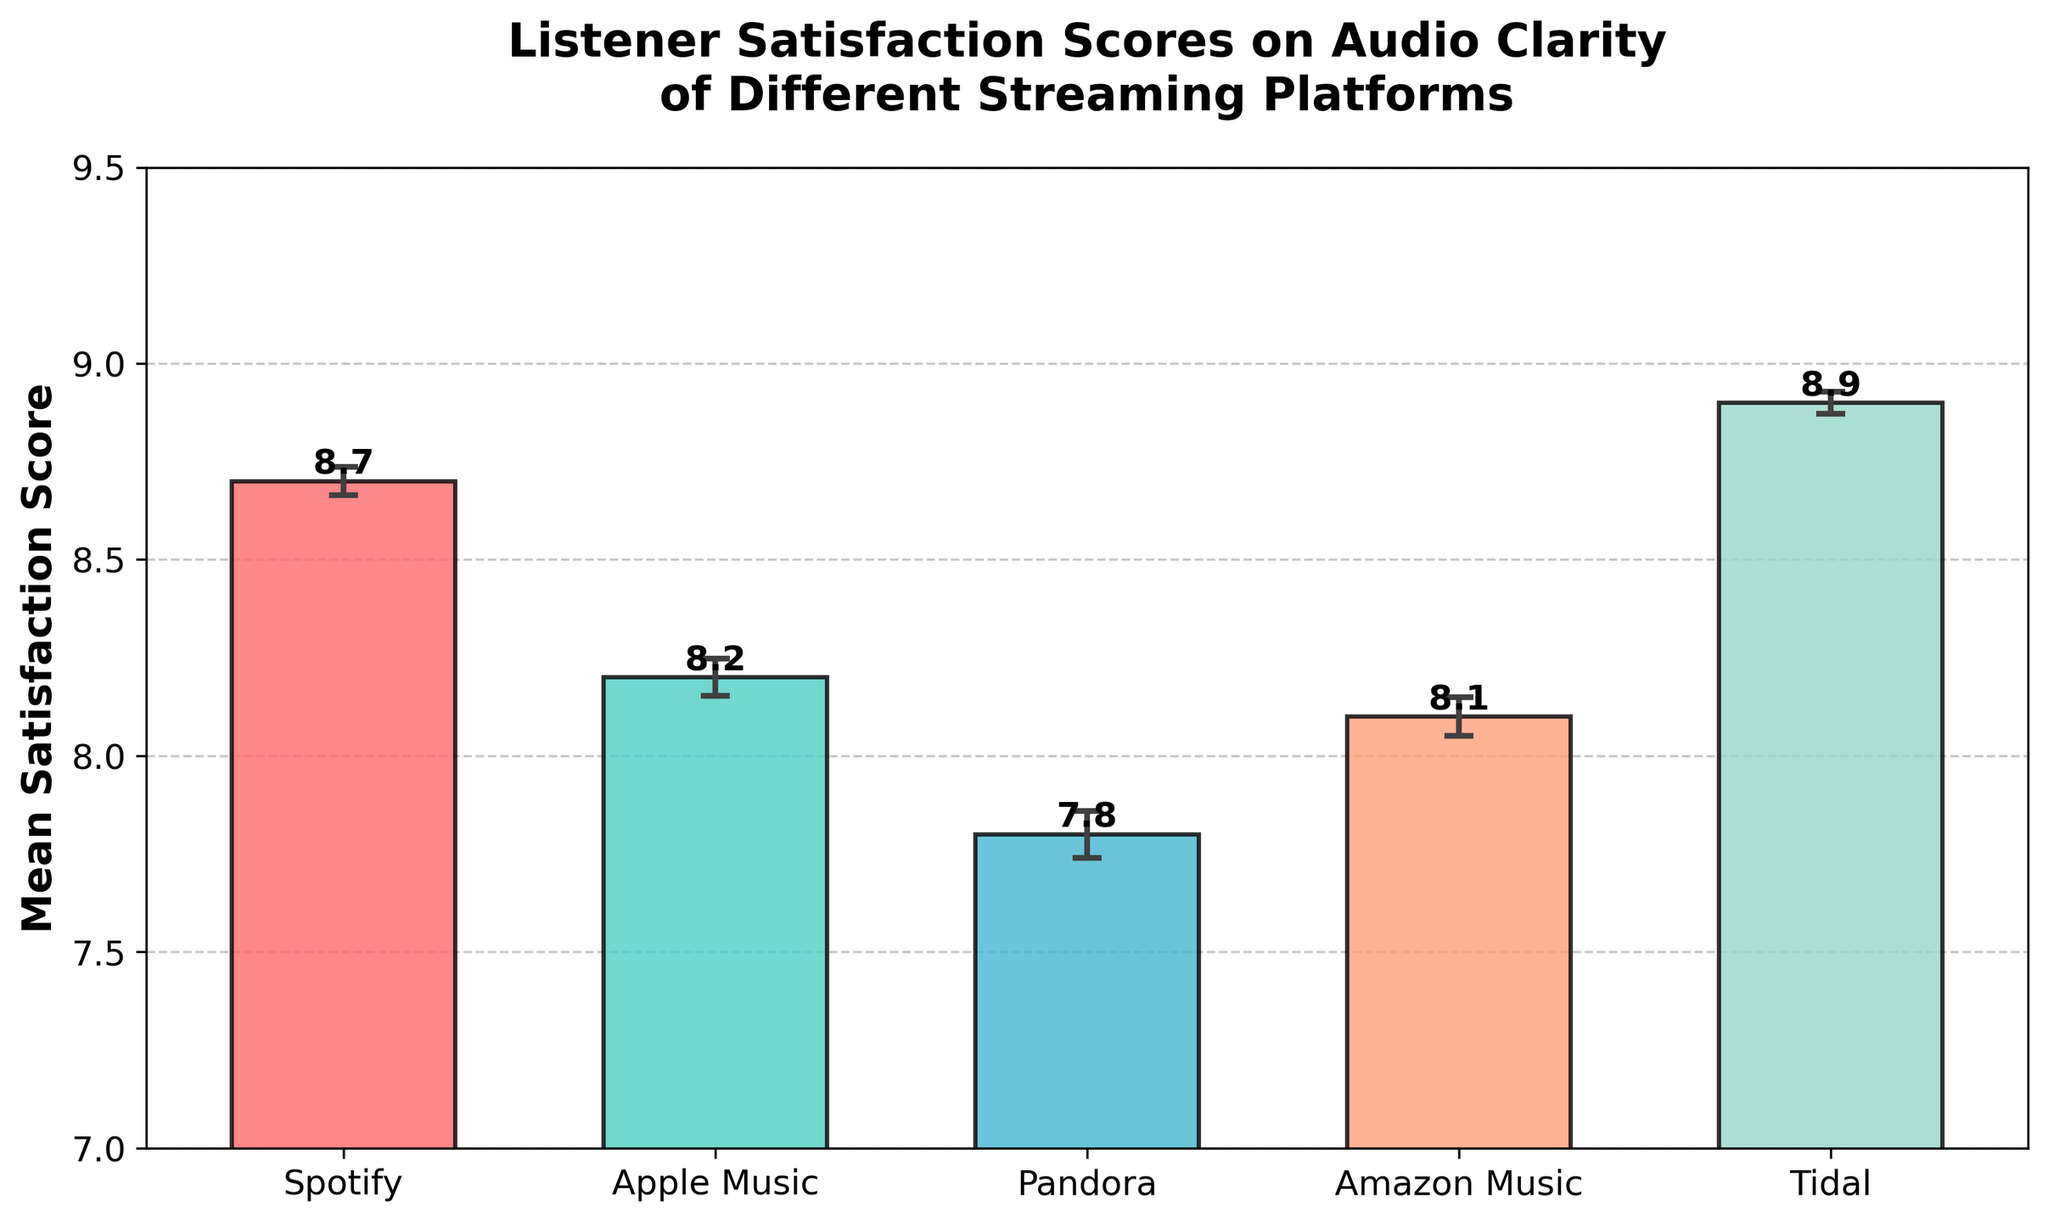What is the title of the chart? The title of the chart is located at the top and provides an overall summary of the data being presented. Here, it explicitly states the subject of the figure.
Answer: Listener Satisfaction Scores on Audio Clarity of Different Streaming Platforms What platforms are being compared in this chart? The platforms are listed along the x-axis and represent the categorical data. They are identified as labels beneath each bar in the bar chart.
Answer: Spotify, Apple Music, Pandora, Amazon Music, Tidal What is the average satisfaction score for Tidal? To find this, locate the bar labeled "Tidal" on the x-axis and refer to its height value, often annotated above the bar.
Answer: 8.9 Which platform has the highest mean satisfaction score? Scan the bars to identify the tallest one, which corresponds to the highest value on the y-axis.
Answer: Tidal What is the difference in mean satisfaction scores between Spotify and Pandora? Find the mean satisfaction for both Spotify and Pandora from their respective bars and subtract the smaller value from the larger one. Spotify: 8.7, Pandora: 7.8. Difference: 8.7 - 7.8
Answer: 0.9 What is the mean error bar length for Apple Music? The error bar length represents the margin of error for Apple Music. It is the length of the vertical line extending above and below its mean satisfaction score. Calculate using the formula for standard error: 0.5 / sqrt(110).
Answer: Approximately 0.048 What is the average mean satisfaction score of all the platforms combined? Sum the mean satisfaction scores of all platforms and then divide by the number of platforms. (8.7 + 8.2 + 7.8 + 8.1 + 8.9) / 5 = 41.7 / 5
Answer: 8.34 Which platform has the smallest error bar, indicating the highest confidence in the satisfaction score? Examine the lengths of the error bars for each platform and identify the shortest one.
Answer: Tidal How does the satisfaction score of Amazon Music compare to Apple Music? Compare the heights of the bars for Amazon Music and Apple Music on the y-axis.
Answer: Amazon Music is slightly higher What range does the y-axis cover in this chart? Observe the scale of the y-axis to determine the minimum and maximum values shown. They are often listed at the beginning and the end of the axis.
Answer: 7 to 9.5 